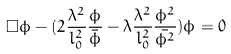<formula> <loc_0><loc_0><loc_500><loc_500>\Box \phi - ( 2 \frac { \lambda ^ { 2 } } { l _ { 0 } ^ { 2 } } \frac { \phi } { \bar { \phi } } - \lambda \frac { \lambda ^ { 2 } } { l _ { 0 } ^ { 2 } } \frac { \phi ^ { 2 } } { \bar { \phi ^ { 2 } } } ) \phi = 0</formula> 